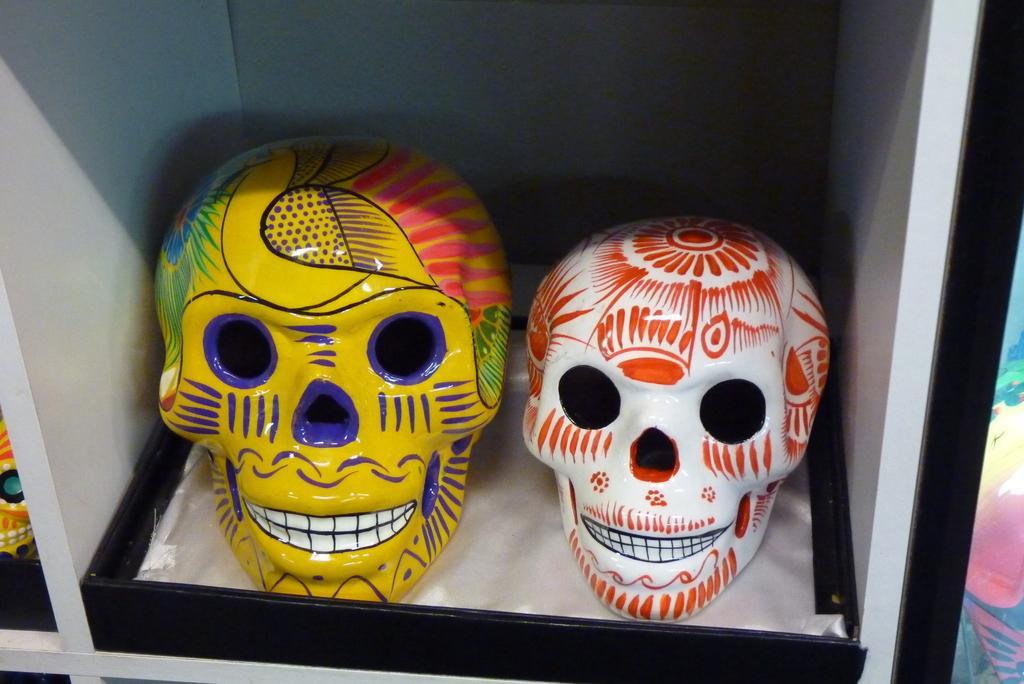Can you describe this image briefly? In the image we can see decorated face skeletons kept in the box. 